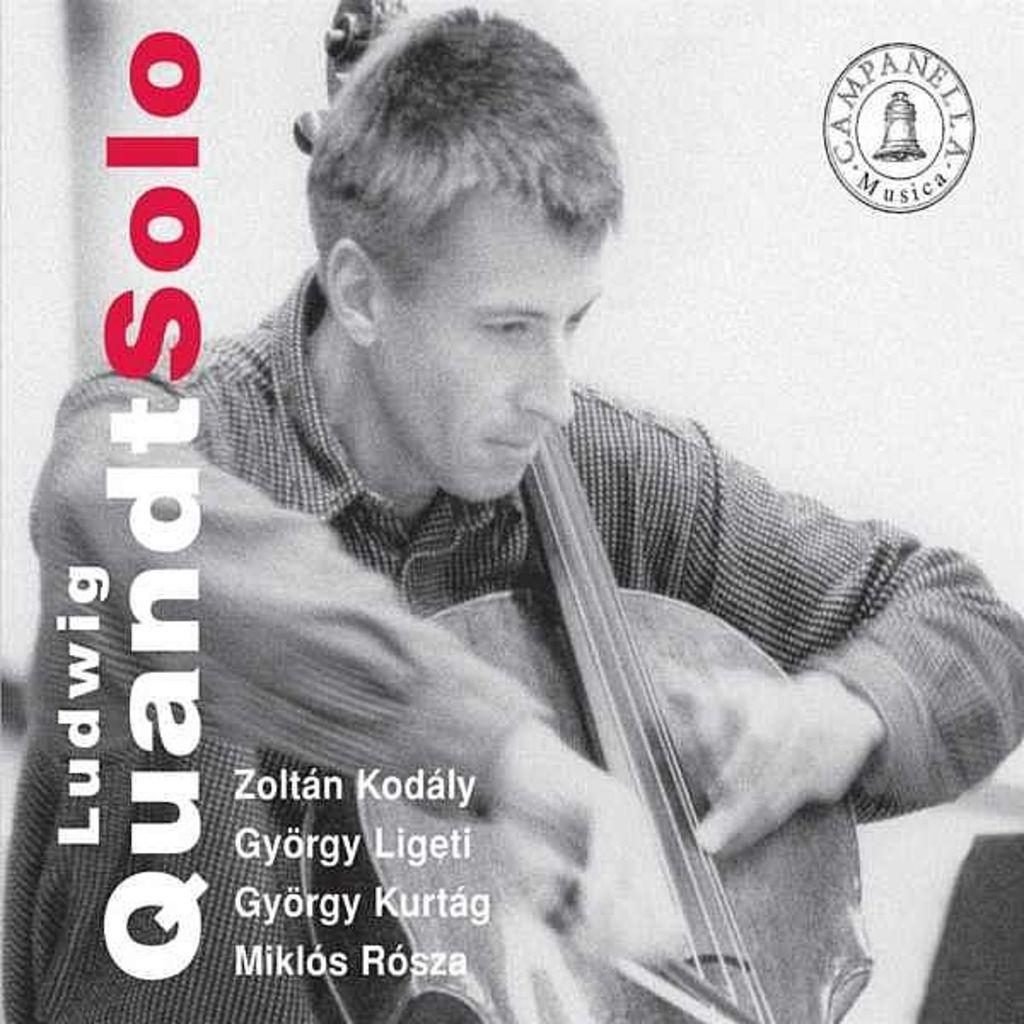What is the main subject of the image? There is a person playing a musical instrument in the image. What else can be seen on the left side of the image? There is text on the left side of the image. Is there any branding or identification in the image? Yes, there is a logo at the top right of the image. How many dolls are sitting in the carriage in the image? There are no dolls or carriages present in the image. What type of hairstyle does the person playing the musical instrument have? The provided facts do not mention the person's hairstyle, so it cannot be determined from the image. 